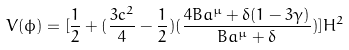<formula> <loc_0><loc_0><loc_500><loc_500>V ( \phi ) = [ \frac { 1 } { 2 } + ( \frac { 3 c ^ { 2 } } { 4 } - \frac { 1 } { 2 } ) ( \frac { 4 B a ^ { \mu } + \delta ( 1 - 3 \gamma ) } { B a ^ { \mu } + \delta } ) ] H ^ { 2 }</formula> 